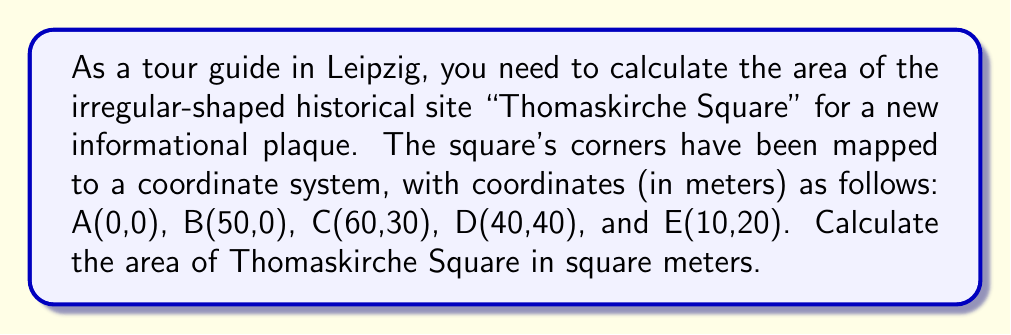What is the answer to this math problem? To calculate the area of this irregular polygon, we'll use the Shoelace formula (also known as the surveyor's formula). The steps are as follows:

1) List the vertices in clockwise or counterclockwise order:
   A(0,0), B(50,0), C(60,30), D(40,40), E(10,20), A(0,0)

2) Apply the Shoelace formula:
   $$Area = \frac{1}{2}|(x_1y_2 + x_2y_3 + ... + x_ny_1) - (y_1x_2 + y_2x_3 + ... + y_nx_1)|$$

3) Substitute the values:
   $$\begin{align*}
   Area &= \frac{1}{2}|(0 \cdot 0 + 50 \cdot 30 + 60 \cdot 40 + 40 \cdot 20 + 10 \cdot 0) \\
   &\quad - (0 \cdot 50 + 0 \cdot 60 + 30 \cdot 40 + 40 \cdot 10 + 20 \cdot 0)|
   \end{align*}$$

4) Calculate:
   $$\begin{align*}
   Area &= \frac{1}{2}|(1500 + 2400 + 800 + 0) - (0 + 0 + 1200 + 400 + 0)| \\
   &= \frac{1}{2}|4700 - 1600| \\
   &= \frac{1}{2} \cdot 3100 \\
   &= 1550
   \end{align*}$$

Therefore, the area of Thomaskirche Square is 1550 square meters.
Answer: 1550 m² 